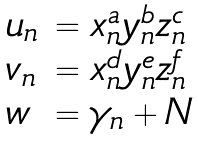Convert formula to latex. <formula><loc_0><loc_0><loc_500><loc_500>\begin{array} { l l } u _ { n } & = x _ { n } ^ { a } y _ { n } ^ { b } z _ { n } ^ { c } \\ v _ { n } & = x _ { n } ^ { d } y _ { n } ^ { e } z _ { n } ^ { f } \\ w & = \gamma _ { n } + N \end{array}</formula> 